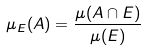Convert formula to latex. <formula><loc_0><loc_0><loc_500><loc_500>\mu _ { E } ( A ) = \frac { \mu ( A \cap E ) } { \mu ( E ) }</formula> 